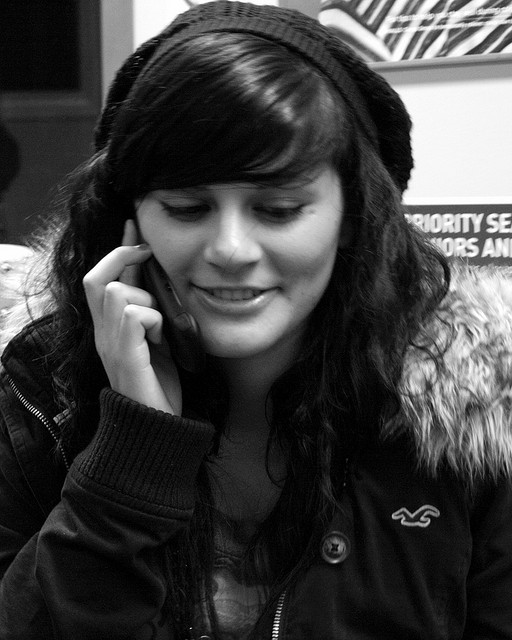<image>What brand is the girl's coat? I am not sure what brand the girl's coat is. It can be 'polar', 'american eagle', 'hollister', 'abercrombie and fitch', 'pelican' or 'faded glory'. What color is the nail polish? I am not sure what the color of the nail polish is. It could possibly be red, gray, pink or black and white. Where are the eyeglasses? There are no eyeglasses in the image. What brand is the girl's coat? I don't know what brand the girl's coat is. What color is the nail polish? It is not sure what color the nail polish is. It can be seen red, gray, pink or black and white. Where are the eyeglasses? I don't know where the eyeglasses are. It seems like they are not in the image. 